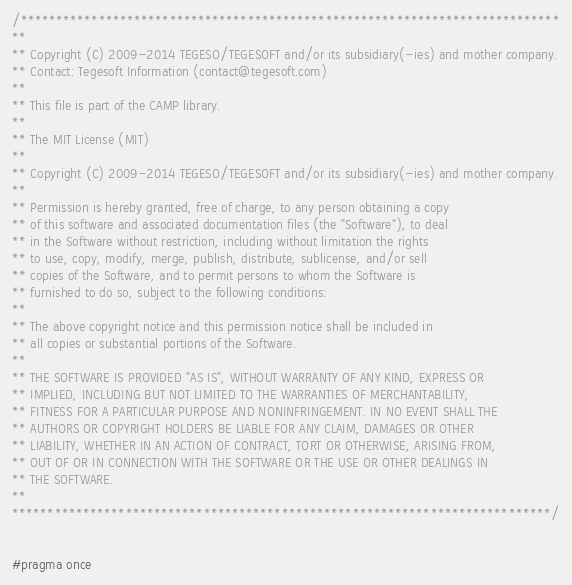Convert code to text. <code><loc_0><loc_0><loc_500><loc_500><_C++_>/****************************************************************************
**
** Copyright (C) 2009-2014 TEGESO/TEGESOFT and/or its subsidiary(-ies) and mother company.
** Contact: Tegesoft Information (contact@tegesoft.com)
**
** This file is part of the CAMP library.
**
** The MIT License (MIT)
**
** Copyright (C) 2009-2014 TEGESO/TEGESOFT and/or its subsidiary(-ies) and mother company.
**
** Permission is hereby granted, free of charge, to any person obtaining a copy
** of this software and associated documentation files (the "Software"), to deal
** in the Software without restriction, including without limitation the rights
** to use, copy, modify, merge, publish, distribute, sublicense, and/or sell
** copies of the Software, and to permit persons to whom the Software is
** furnished to do so, subject to the following conditions:
** 
** The above copyright notice and this permission notice shall be included in
** all copies or substantial portions of the Software.
** 
** THE SOFTWARE IS PROVIDED "AS IS", WITHOUT WARRANTY OF ANY KIND, EXPRESS OR
** IMPLIED, INCLUDING BUT NOT LIMITED TO THE WARRANTIES OF MERCHANTABILITY,
** FITNESS FOR A PARTICULAR PURPOSE AND NONINFRINGEMENT. IN NO EVENT SHALL THE
** AUTHORS OR COPYRIGHT HOLDERS BE LIABLE FOR ANY CLAIM, DAMAGES OR OTHER
** LIABILITY, WHETHER IN AN ACTION OF CONTRACT, TORT OR OTHERWISE, ARISING FROM,
** OUT OF OR IN CONNECTION WITH THE SOFTWARE OR THE USE OR OTHER DEALINGS IN
** THE SOFTWARE.
**
****************************************************************************/


#pragma once

</code> 